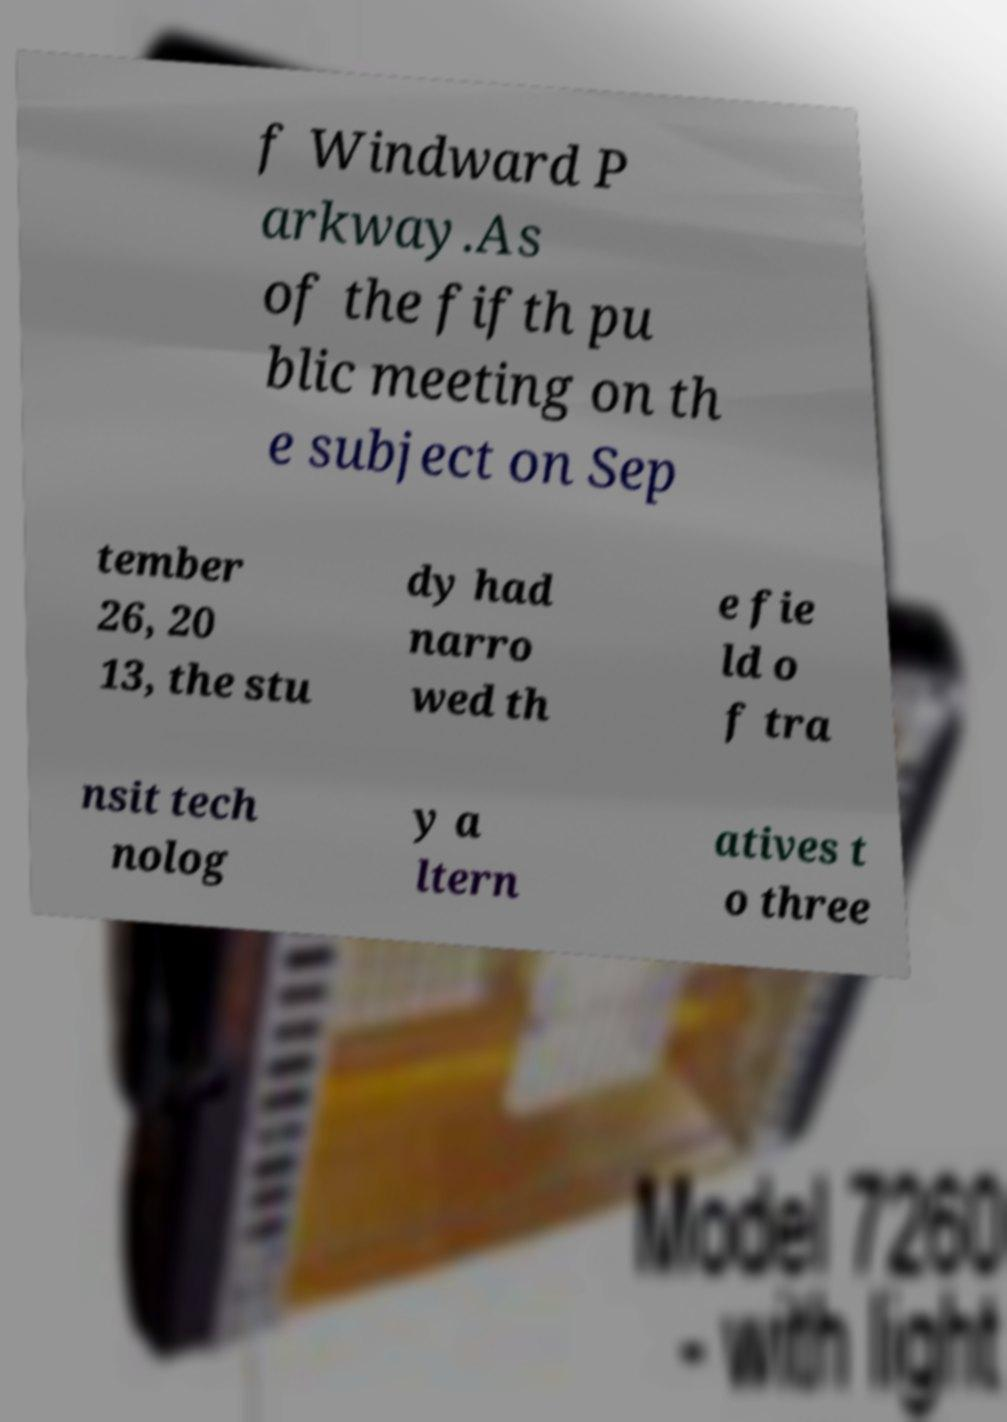Please read and relay the text visible in this image. What does it say? f Windward P arkway.As of the fifth pu blic meeting on th e subject on Sep tember 26, 20 13, the stu dy had narro wed th e fie ld o f tra nsit tech nolog y a ltern atives t o three 